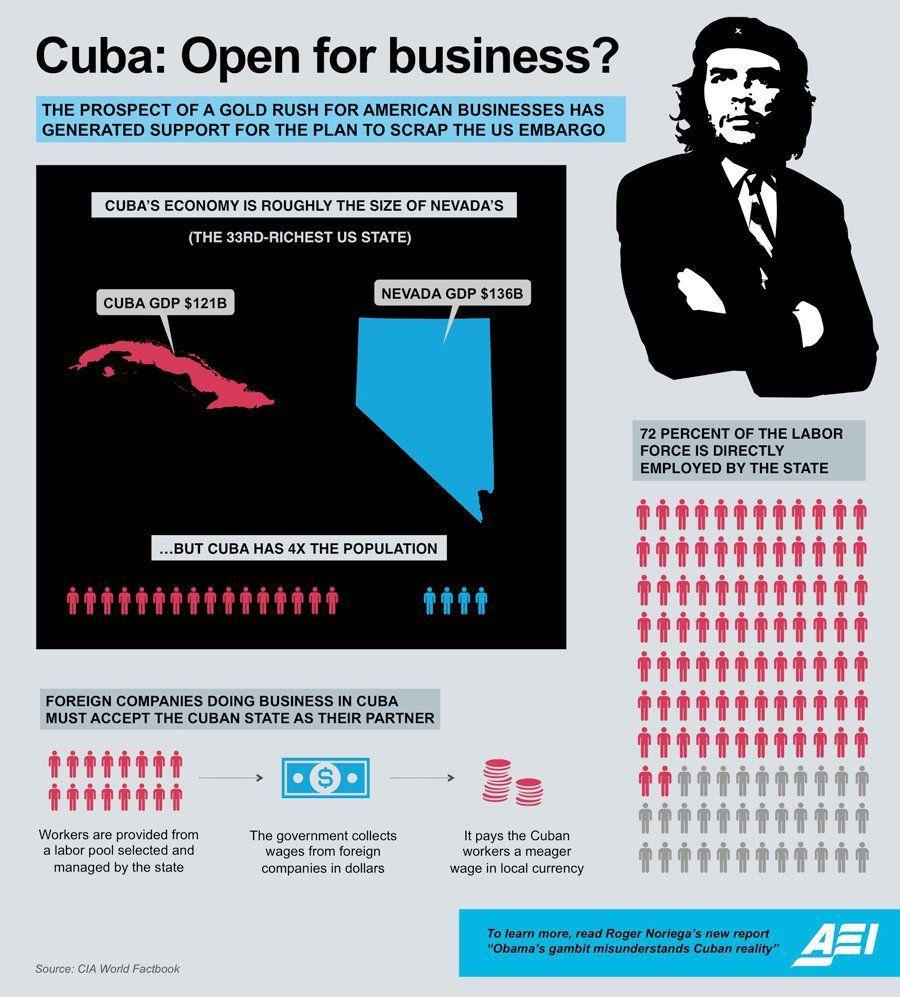Which is the 33rd richest US state?
Answer the question with a short phrase. NEVADA Which currency is collected by Cuba from other companies? dollars How big is the population of Cuba compared to Nevada? 4X 